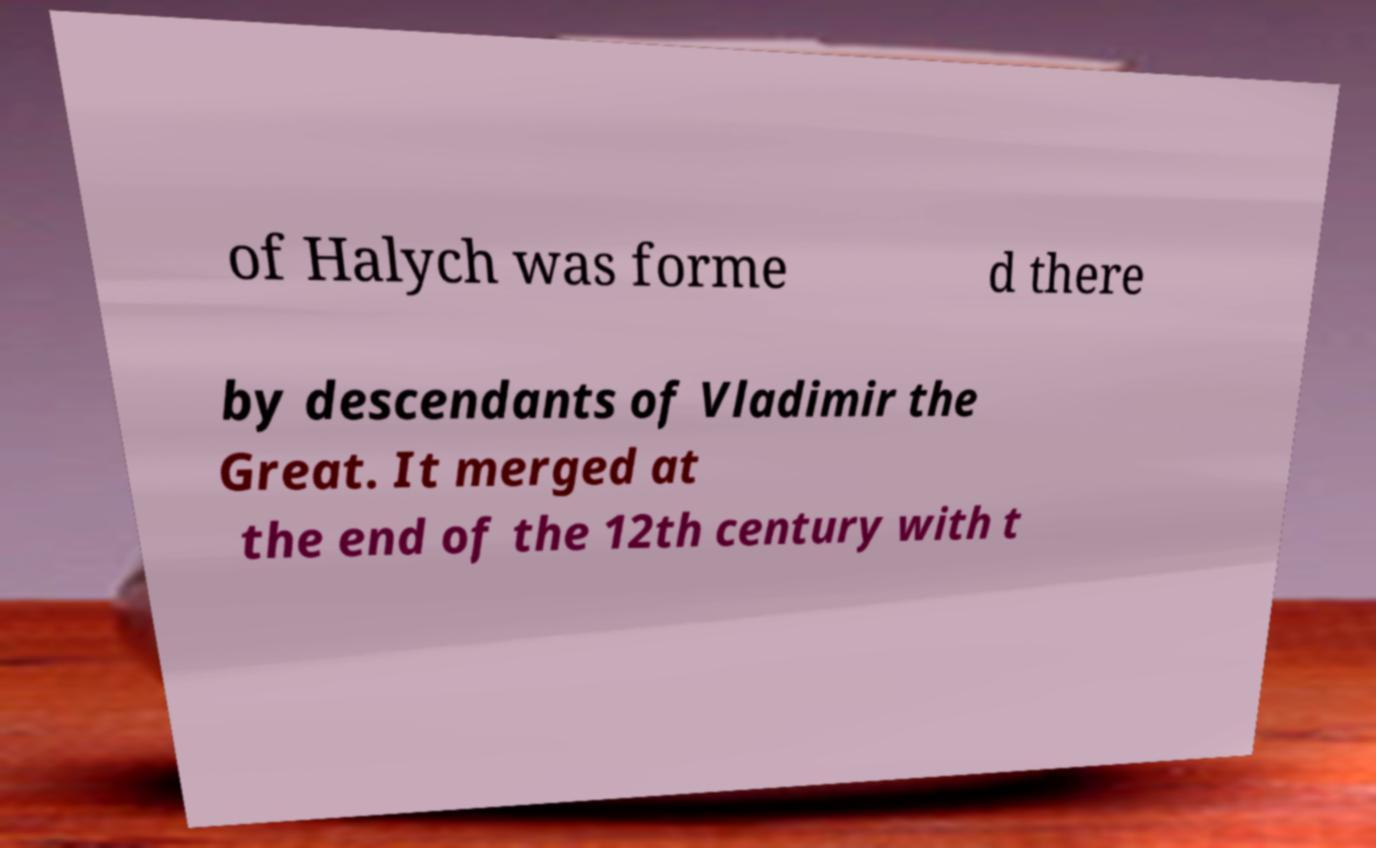Can you read and provide the text displayed in the image?This photo seems to have some interesting text. Can you extract and type it out for me? of Halych was forme d there by descendants of Vladimir the Great. It merged at the end of the 12th century with t 